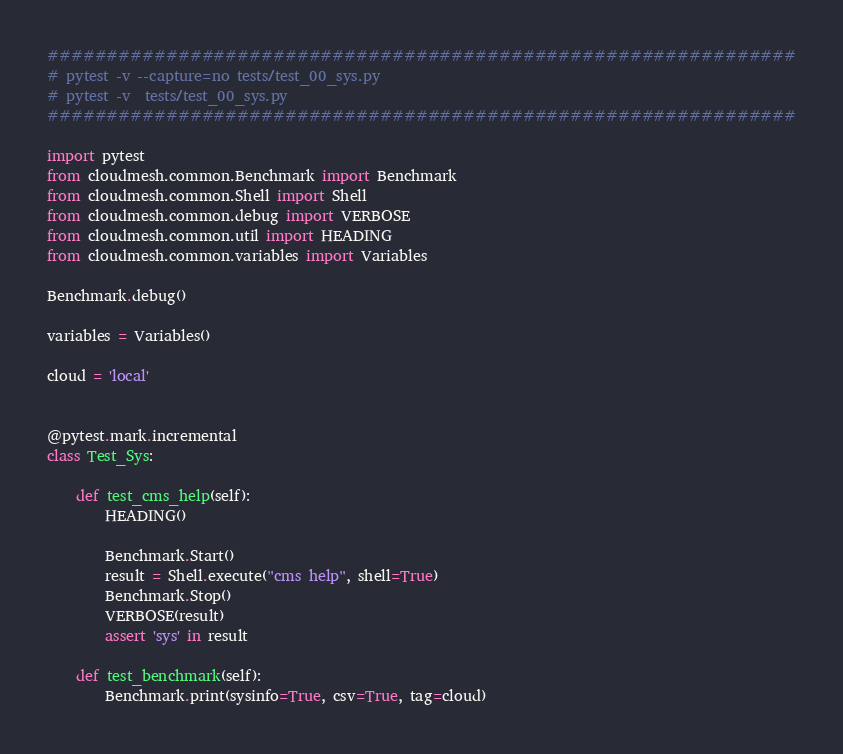<code> <loc_0><loc_0><loc_500><loc_500><_Python_>###############################################################
# pytest -v --capture=no tests/test_00_sys.py
# pytest -v  tests/test_00_sys.py
###############################################################

import pytest
from cloudmesh.common.Benchmark import Benchmark
from cloudmesh.common.Shell import Shell
from cloudmesh.common.debug import VERBOSE
from cloudmesh.common.util import HEADING
from cloudmesh.common.variables import Variables

Benchmark.debug()

variables = Variables()

cloud = 'local'


@pytest.mark.incremental
class Test_Sys:

    def test_cms_help(self):
        HEADING()

        Benchmark.Start()
        result = Shell.execute("cms help", shell=True)
        Benchmark.Stop()
        VERBOSE(result)
        assert 'sys' in result

    def test_benchmark(self):
        Benchmark.print(sysinfo=True, csv=True, tag=cloud)
</code> 